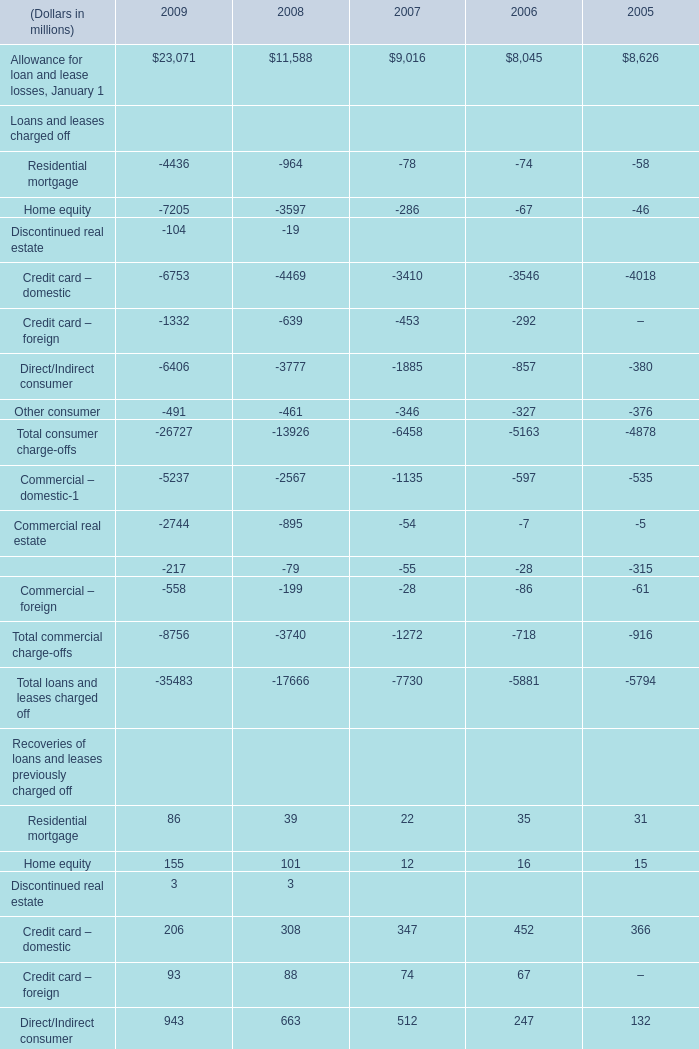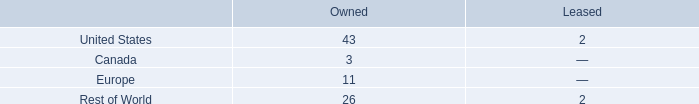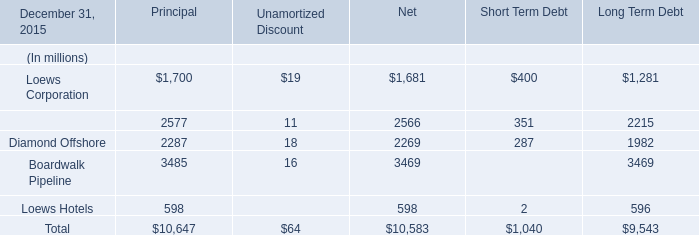What's the total amount of consumer charge-offs excluding Residential mortgage and Discontinued real estate in 2009? (in dollars in millions) 
Computations: ((((-7205 - 6753) - 1332) - 6406) - 491)
Answer: -22187.0. 